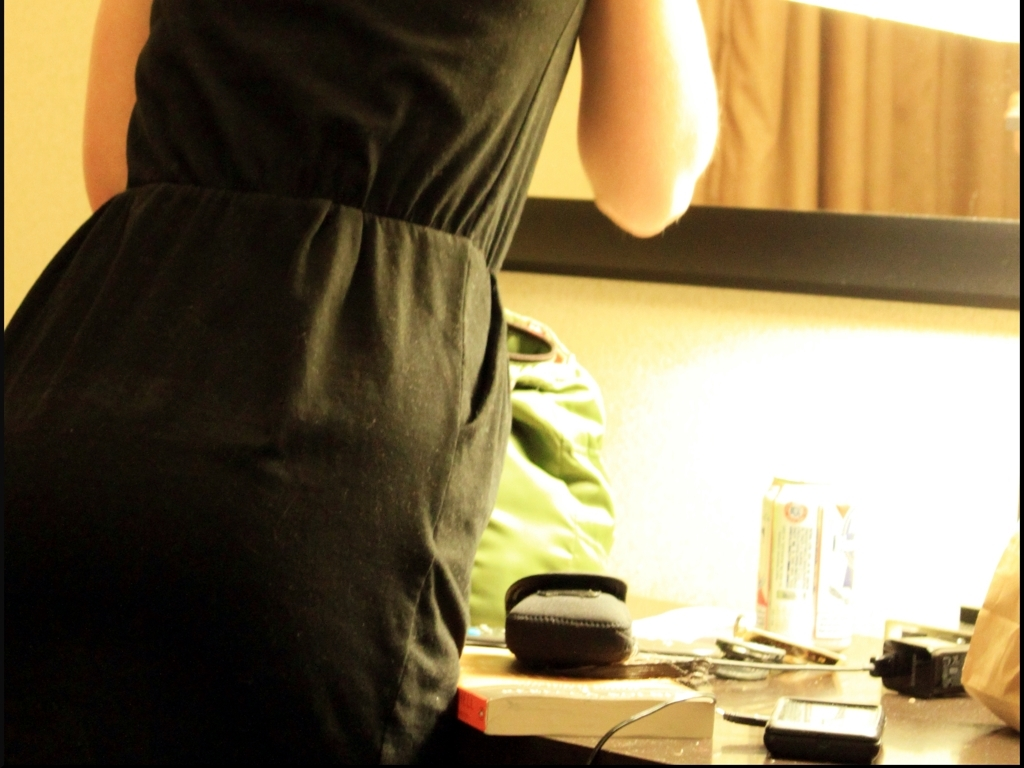How could this image be interpreted artistically? Artistically, the image could be seen as a commentary on modern life's chaos and busyness, where the personal space becomes cluttered with the day's remnants. The overexposure and blurriness might be employed deliberately to invoke a sense of impermanence and the transitory nature of time. 